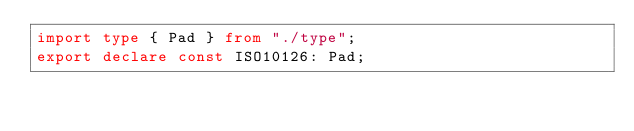Convert code to text. <code><loc_0><loc_0><loc_500><loc_500><_TypeScript_>import type { Pad } from "./type";
export declare const ISO10126: Pad;
</code> 